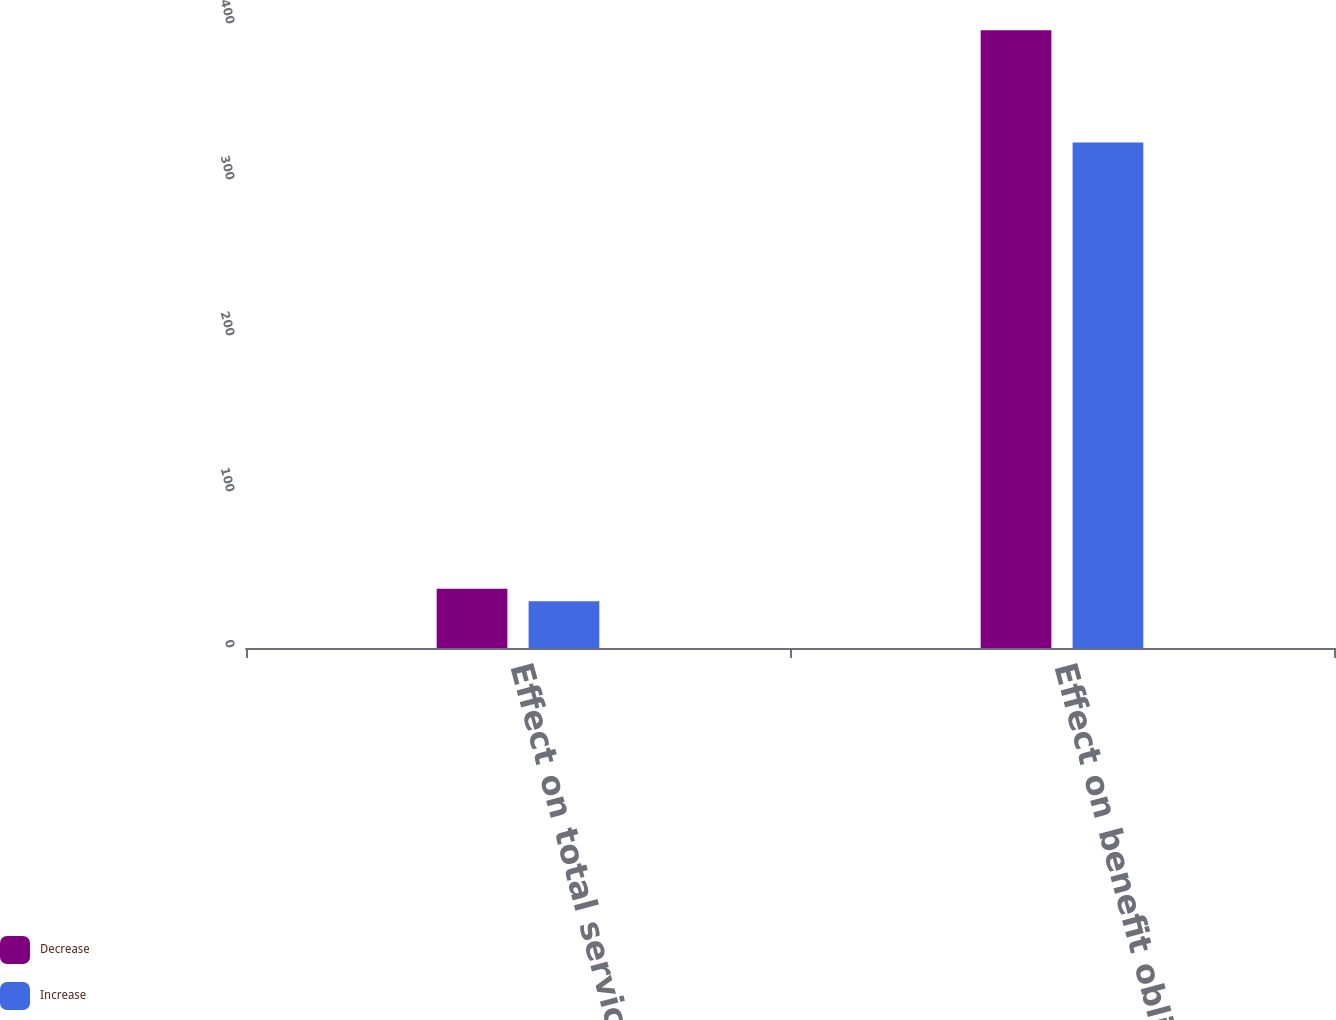Convert chart to OTSL. <chart><loc_0><loc_0><loc_500><loc_500><stacked_bar_chart><ecel><fcel>Effect on total service and<fcel>Effect on benefit obligation<nl><fcel>Decrease<fcel>38<fcel>396<nl><fcel>Increase<fcel>30<fcel>324<nl></chart> 